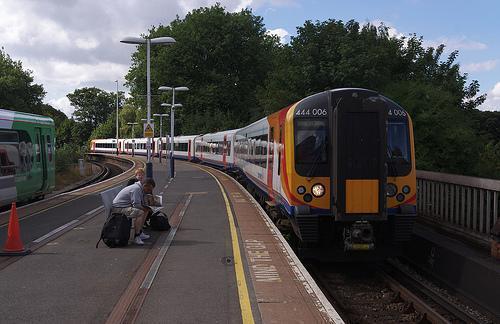How many people are there?
Give a very brief answer. 2. How many trains are there?
Give a very brief answer. 2. 